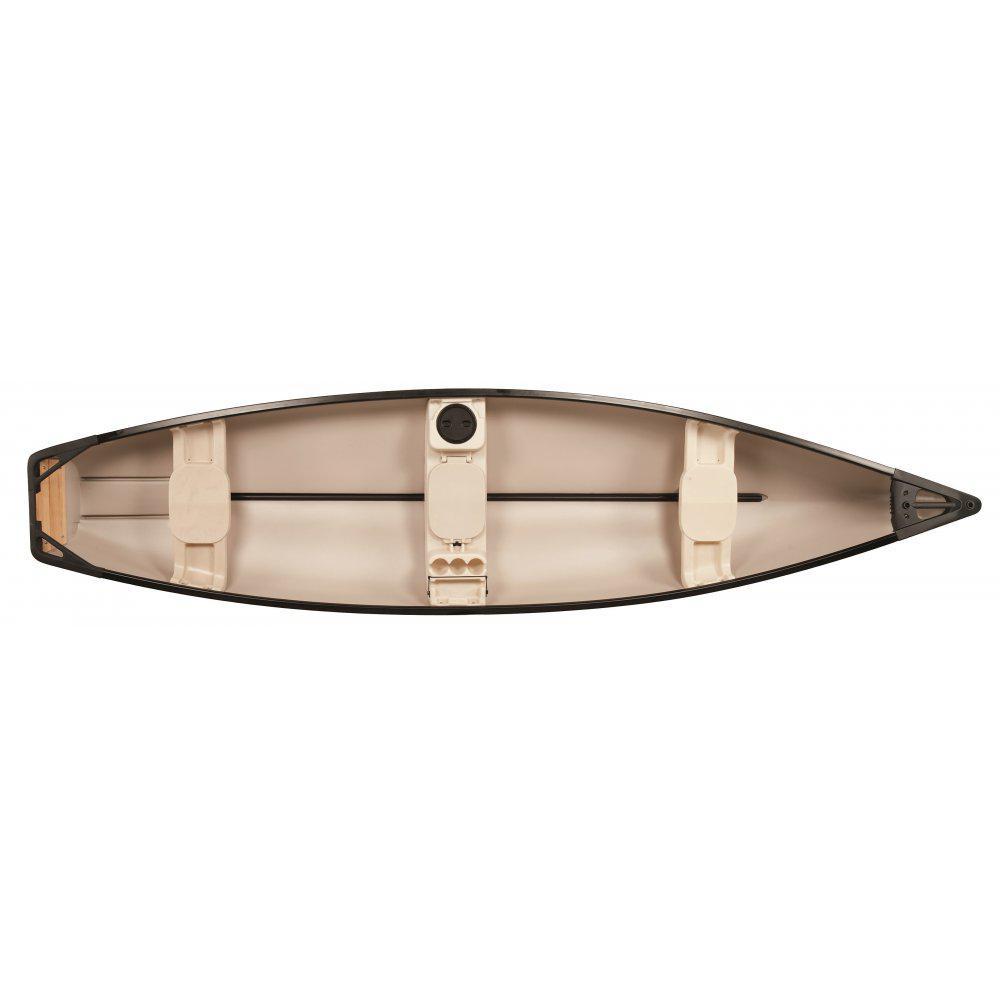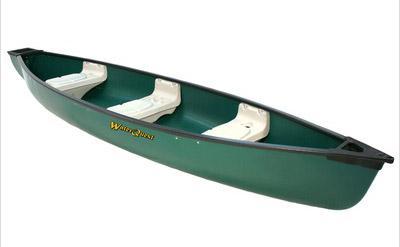The first image is the image on the left, the second image is the image on the right. Given the left and right images, does the statement "Both images show top and side angles of a green boat." hold true? Answer yes or no. No. The first image is the image on the left, the second image is the image on the right. Considering the images on both sides, is "At least one image shows a boat displayed horizontally in both side and aerial views." valid? Answer yes or no. No. 